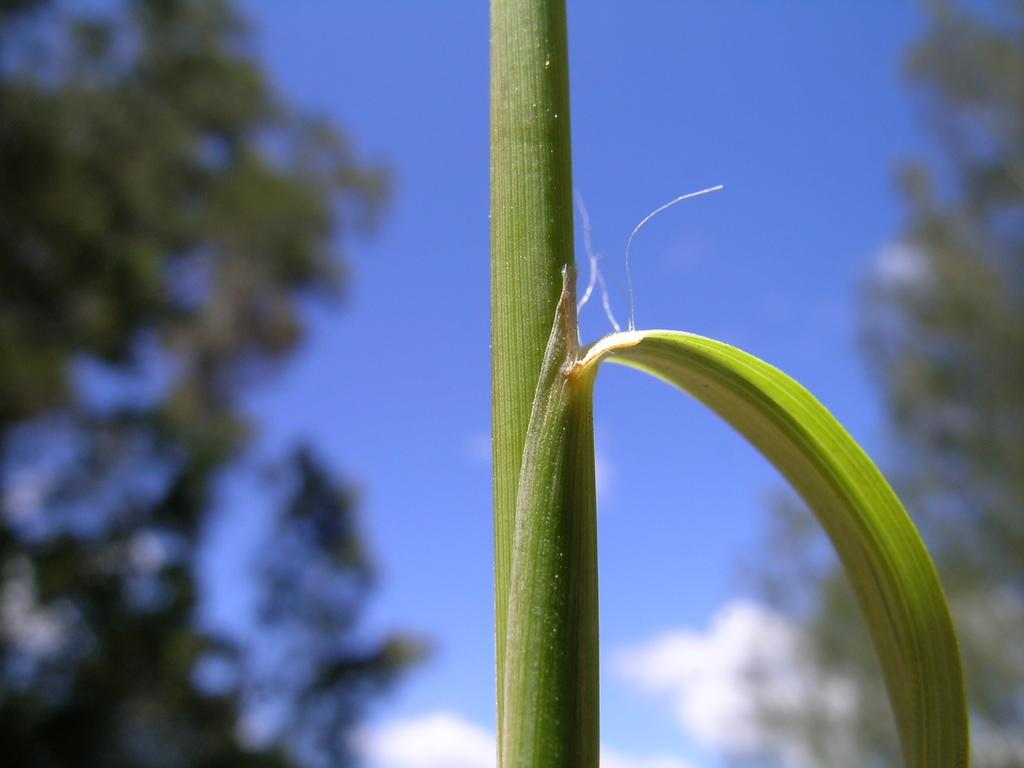What is the main subject in the center of the image? There is a stem in the center of the image. What else can be seen in the image besides the stem? There is a leaf in the image. What can be seen in the background of the image? There are trees and the sky visible in the background of the image. How many passengers are visible in the image? There are no passengers present in the image. What type of whip is being used in the image? There is no whip present in the image. 